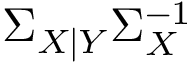<formula> <loc_0><loc_0><loc_500><loc_500>\Sigma _ { X | Y } \Sigma _ { X } ^ { - 1 }</formula> 